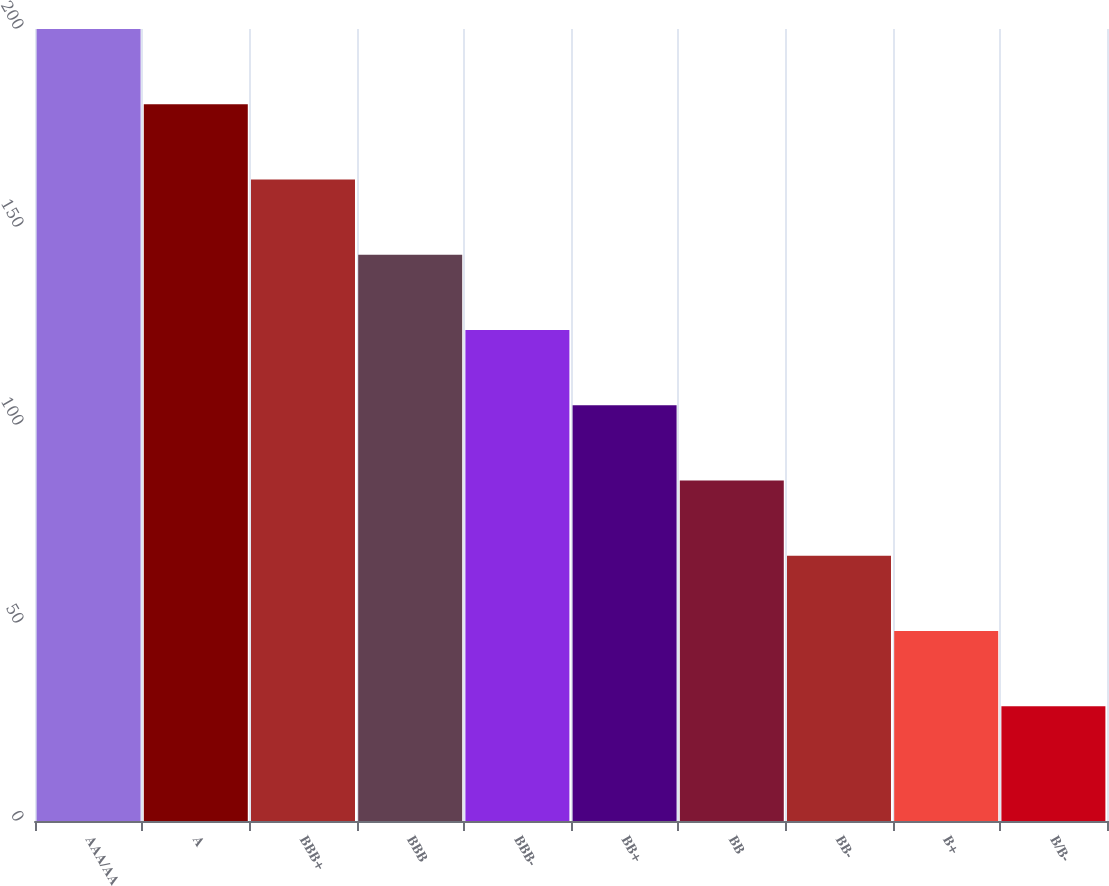Convert chart. <chart><loc_0><loc_0><loc_500><loc_500><bar_chart><fcel>AAA/AA<fcel>A<fcel>BBB+<fcel>BBB<fcel>BBB-<fcel>BB+<fcel>BB<fcel>BB-<fcel>B+<fcel>B/B-<nl><fcel>200<fcel>181<fcel>162<fcel>143<fcel>124<fcel>105<fcel>86<fcel>67<fcel>48<fcel>29<nl></chart> 